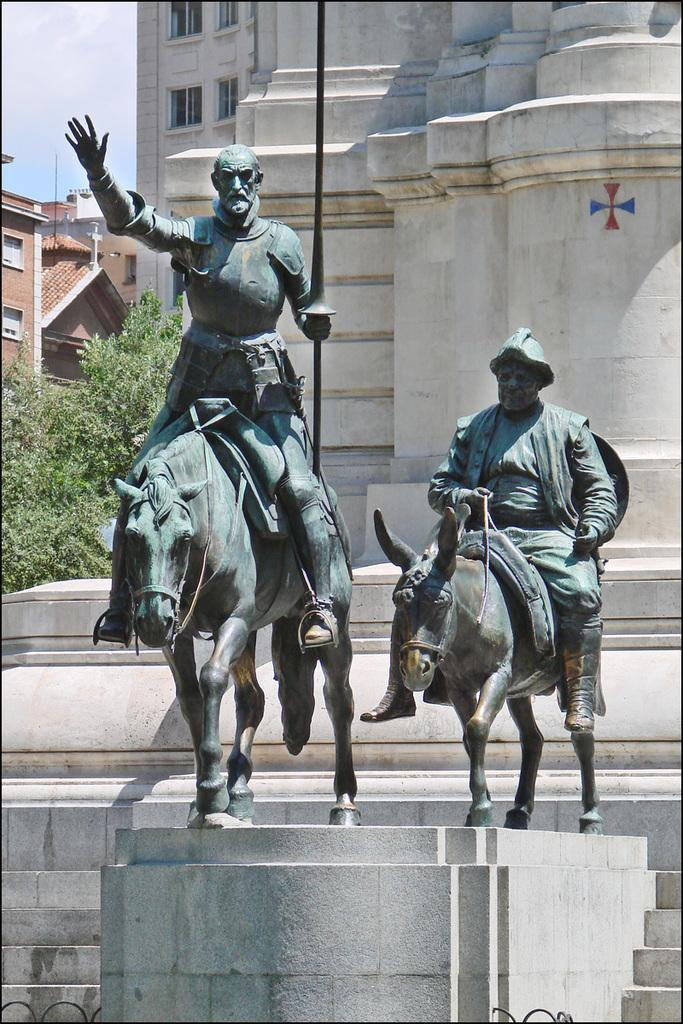What type of objects can be seen in the image? There are statues in the image. What can be seen in the distance behind the statues? There are buildings and trees in the background of the image. Are there any architectural features in the image or its background? Yes, there are stairs in the image or its background. Can you tell me how many robins are perched on the statues in the image? There are no robins present in the image; it features statues, buildings, trees, and stairs. What type of tool is being used to copy the statues in the image? There is no tool or action of copying the statues in the image; it simply displays the statues as they are. 